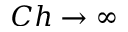<formula> <loc_0><loc_0><loc_500><loc_500>C h \rightarrow \infty</formula> 